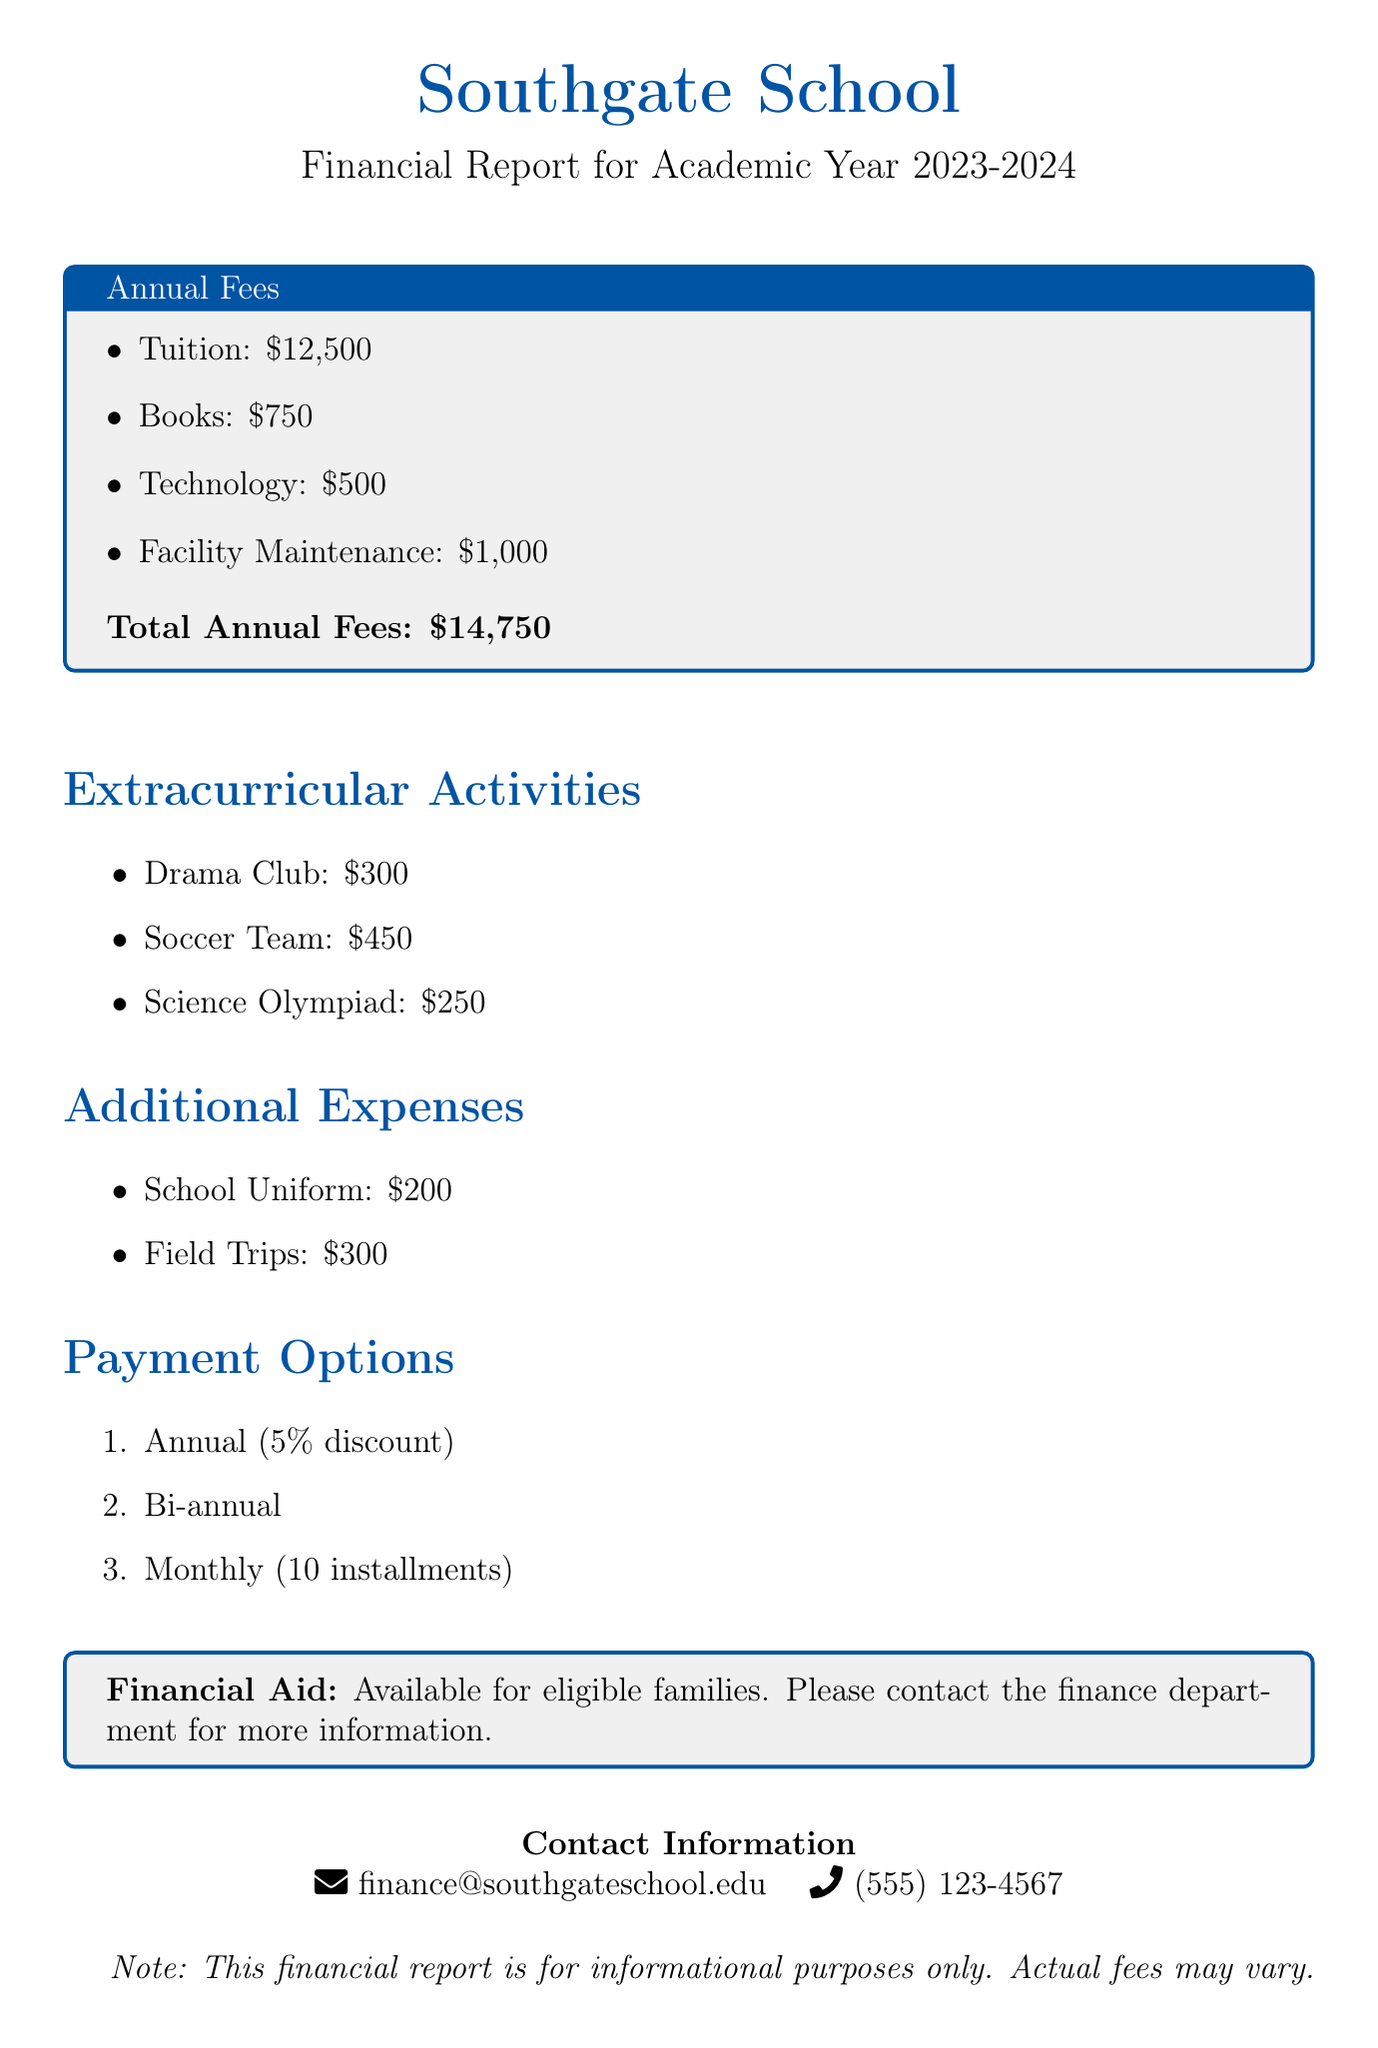what is the total annual fee? The total annual fee is calculated by summing tuition, books, technology, and facility maintenance fees.
Answer: $14,750 how much is the fee for the Soccer Team? The fee for the Soccer Team is listed under extracurricular activities.
Answer: $450 what are the payment options available? The list of payment options is provided in the document, which includes three methods.
Answer: Annual (5% discount), Bi-annual, Monthly (10 installments) which additional expense costs $300? The document lists two additional expenses, one of which is $300.
Answer: Field Trips is financial aid available? The document explicitly states whether financial aid is offered or not.
Answer: Yes what is the fee for books? The fee for books is specifically stated in the annual fees section.
Answer: $750 how much does the Drama Club cost? The fee for the Drama Club is mentioned under extracurricular activities in the document.
Answer: $300 what is the cost of the school uniform? The cost of the school uniform is listed as one of the additional expenses.
Answer: $200 what is the academic year covered in the report? The academic year is specified at the beginning of the document.
Answer: 2023-2024 